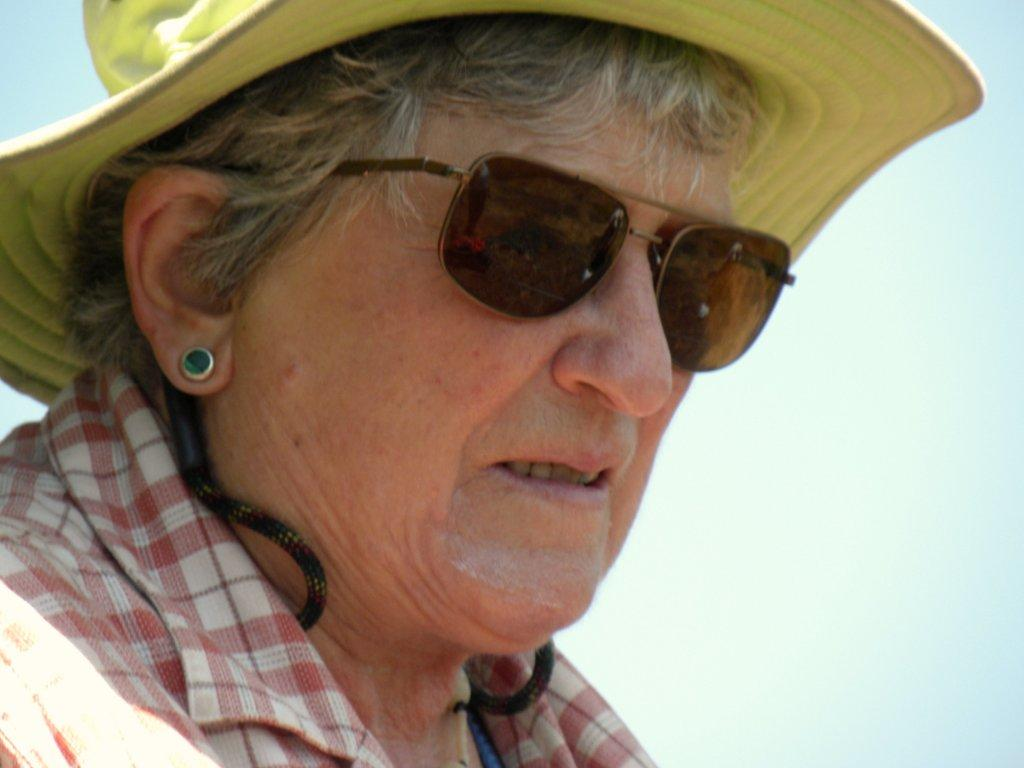Who is the main subject in the image? There is a woman in the image. What is the woman wearing on her upper body? The woman is wearing a red and white check shirt. What type of protective eyewear is the woman wearing? The woman is wearing goggles. What color is the hat the woman is wearing? The woman is wearing a yellow hat. What can be seen in the background of the image? The sky is visible in the background of the image. What type of feather can be seen on the woman's hat in the image? There is no feather visible on the woman's hat in the image. 